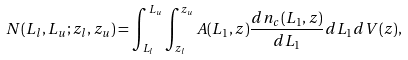<formula> <loc_0><loc_0><loc_500><loc_500>N ( L _ { l } , L _ { u } ; z _ { l } , z _ { u } ) = \int _ { L _ { l } } ^ { L _ { u } } \int _ { z _ { l } } ^ { z _ { u } } A ( L _ { 1 } , z ) \frac { d n _ { c } ( L _ { 1 } , z ) } { d L _ { 1 } } d L _ { 1 } d V ( z ) ,</formula> 